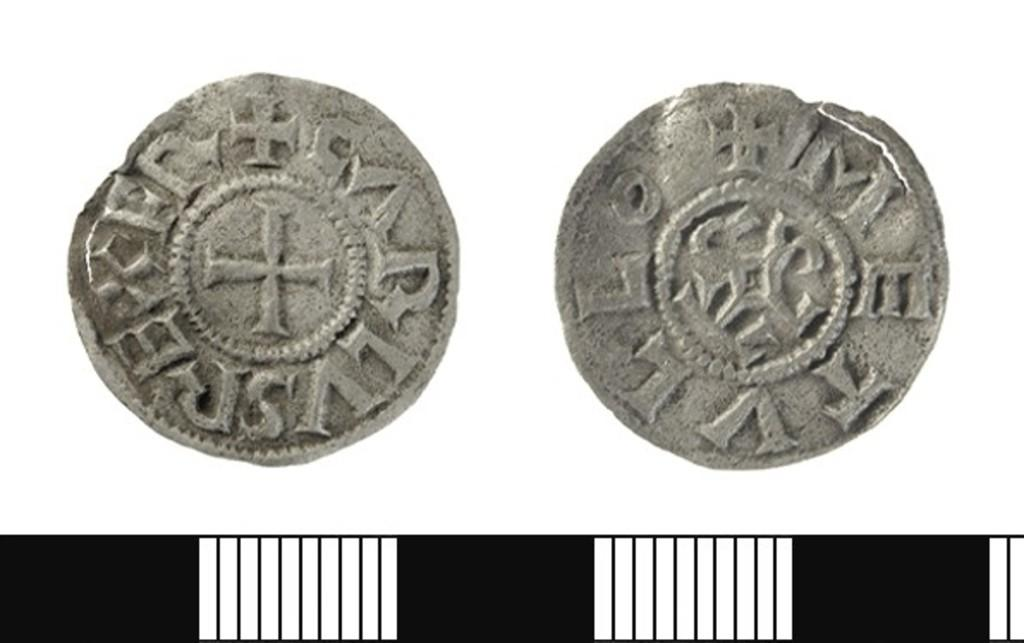<image>
Provide a brief description of the given image. the letter M is on the gray coin that is next to another 